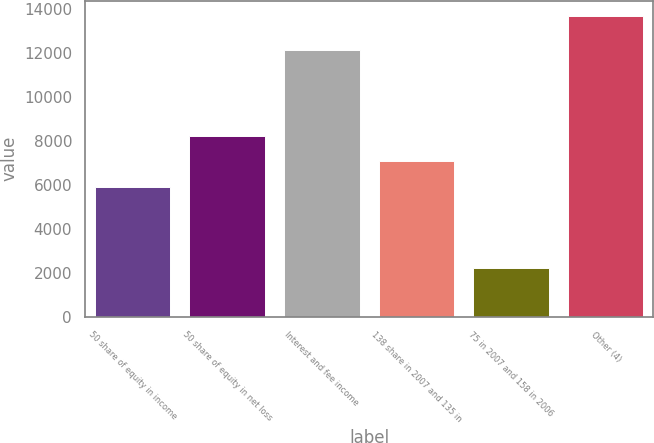Convert chart to OTSL. <chart><loc_0><loc_0><loc_500><loc_500><bar_chart><fcel>50 share of equity in income<fcel>50 share of equity in net loss<fcel>Interest and fee income<fcel>138 share in 2007 and 135 in<fcel>75 in 2007 and 158 in 2006<fcel>Other (4)<nl><fcel>5923<fcel>8220.2<fcel>12141<fcel>7071.6<fcel>2211<fcel>13697<nl></chart> 